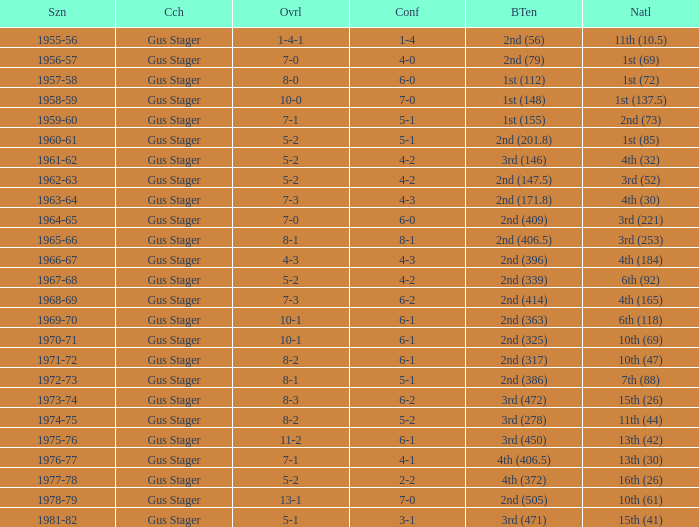What is the Coach with a Big Ten that is 2nd (79)? Gus Stager. 